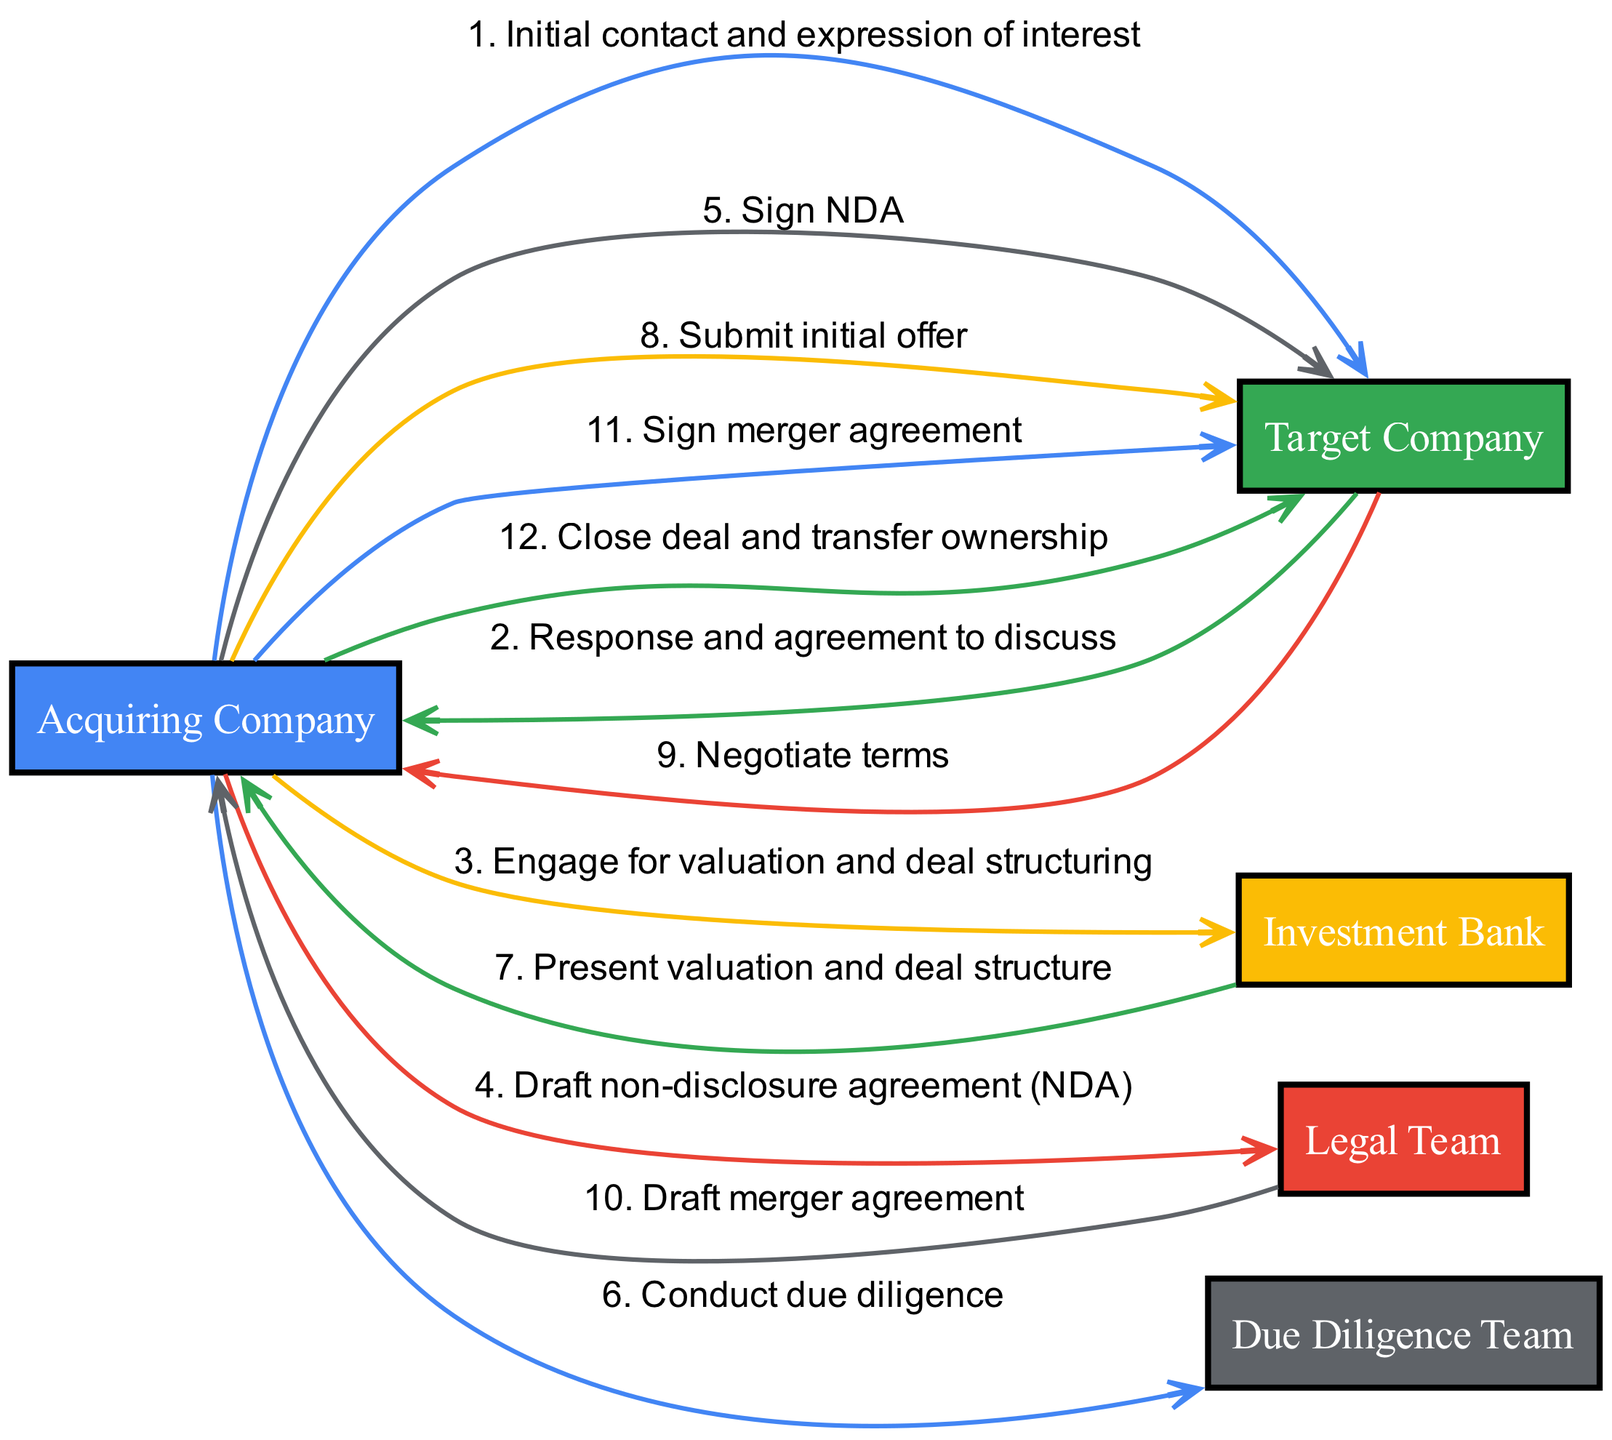What is the first message sent in the sequence? The first message in the sequence is "Initial contact and expression of interest" from the Acquiring Company to the Target Company.
Answer: Initial contact and expression of interest How many actors are involved in this merger and acquisition sequence? The diagram lists five actors involved: Acquiring Company, Target Company, Investment Bank, Legal Team, and Due Diligence Team.
Answer: Five Which actor engages the Investment Bank for valuation? The Acquiring Company engages the Investment Bank for valuation and deal structuring.
Answer: Acquiring Company What is the last event in the sequence? The last event in the sequence is "Close deal and transfer ownership," initiated by the Acquiring Company to the Target Company.
Answer: Close deal and transfer ownership How many messages are exchanged between the Acquiring Company and the Target Company? There are four messages exchanged specifically between the Acquiring Company and the Target Company throughout the sequence.
Answer: Four What role does the Legal Team play in this process? The Legal Team drafts the merger agreement as part of the acquisition process.
Answer: Draft merger agreement At what stage does the Due Diligence Team conduct their work? The Due Diligence Team conducts their work after the Acquiring Company initiates due diligence, following the signing of the non-disclosure agreement.
Answer: After signing NDA Which entity performs the step of negotiating terms? The step of negotiating terms is performed between the Target Company and the Acquiring Company.
Answer: Target Company How does the sequence progress from the initial contact to closing the deal? The sequence progresses through stages including initial contact, response, NDA signing, due diligence, negotiation of terms, and finally signing the merger agreement leading to closing.
Answer: Through stages of contact, NDA, due diligence, negotiation, and closing 